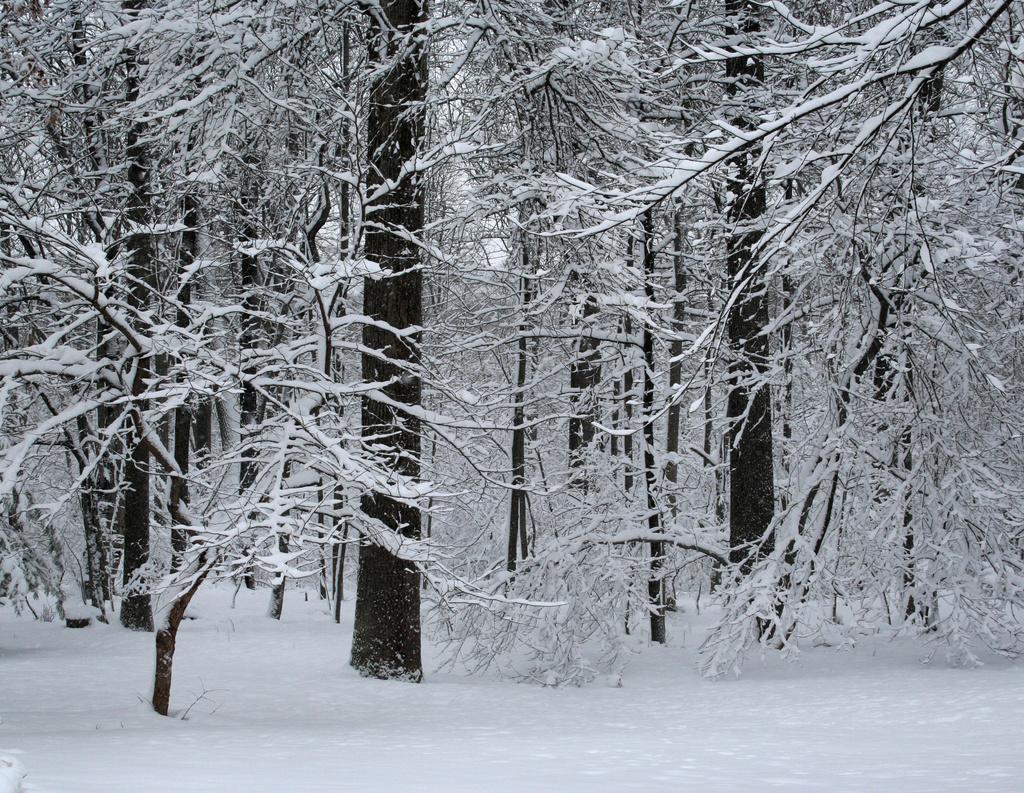Please provide a concise description of this image. This is a black and white image. In this image, we can see some trees which are covered with snow, at the bottom, we can see snow. 